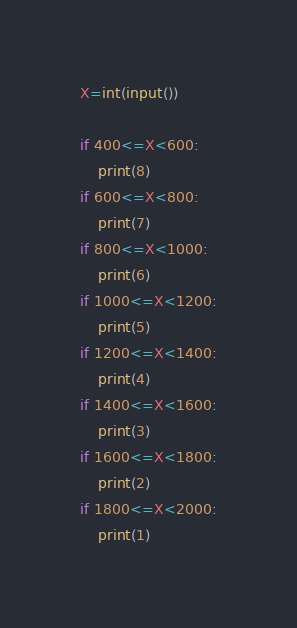Convert code to text. <code><loc_0><loc_0><loc_500><loc_500><_Python_>X=int(input())

if 400<=X<600:
    print(8)
if 600<=X<800:
    print(7)
if 800<=X<1000:
    print(6)
if 1000<=X<1200:
    print(5)
if 1200<=X<1400:
    print(4)
if 1400<=X<1600:
    print(3)
if 1600<=X<1800:
    print(2)
if 1800<=X<2000:
    print(1)
</code> 